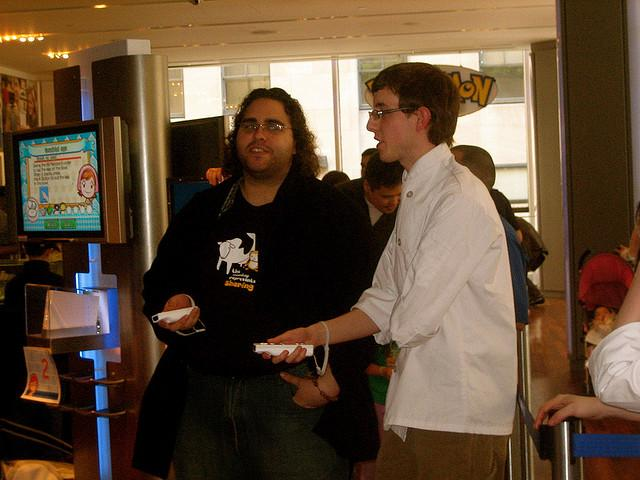What major gaming franchise is being advertised on the window? Please explain your reasoning. pokemon. Pokemon's logo is on the window. 